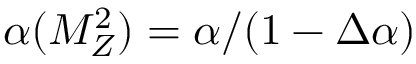Convert formula to latex. <formula><loc_0><loc_0><loc_500><loc_500>\alpha ( M _ { Z } ^ { 2 } ) = \alpha / ( 1 - \Delta \alpha )</formula> 